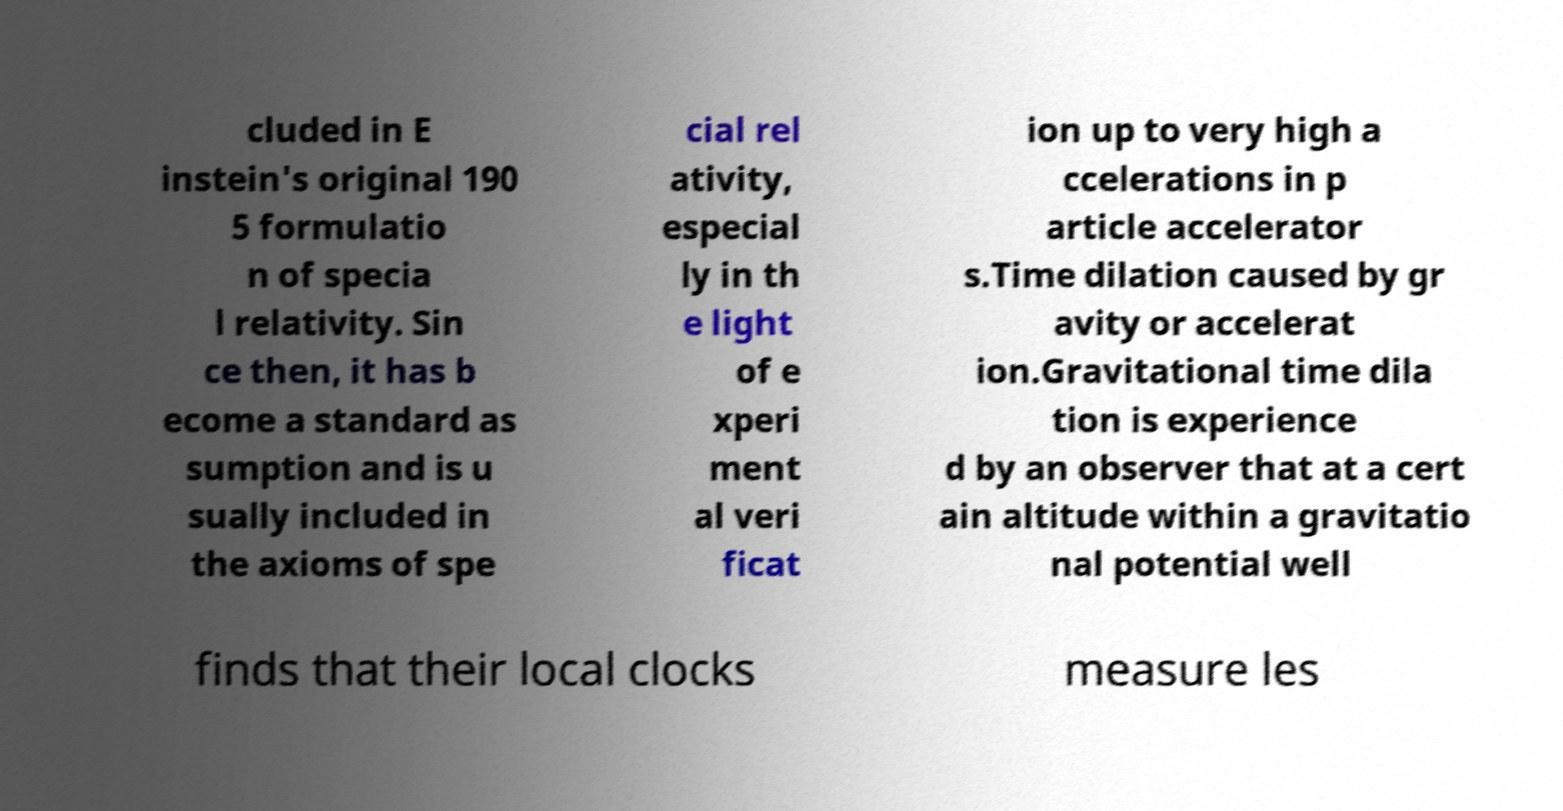Please identify and transcribe the text found in this image. cluded in E instein's original 190 5 formulatio n of specia l relativity. Sin ce then, it has b ecome a standard as sumption and is u sually included in the axioms of spe cial rel ativity, especial ly in th e light of e xperi ment al veri ficat ion up to very high a ccelerations in p article accelerator s.Time dilation caused by gr avity or accelerat ion.Gravitational time dila tion is experience d by an observer that at a cert ain altitude within a gravitatio nal potential well finds that their local clocks measure les 